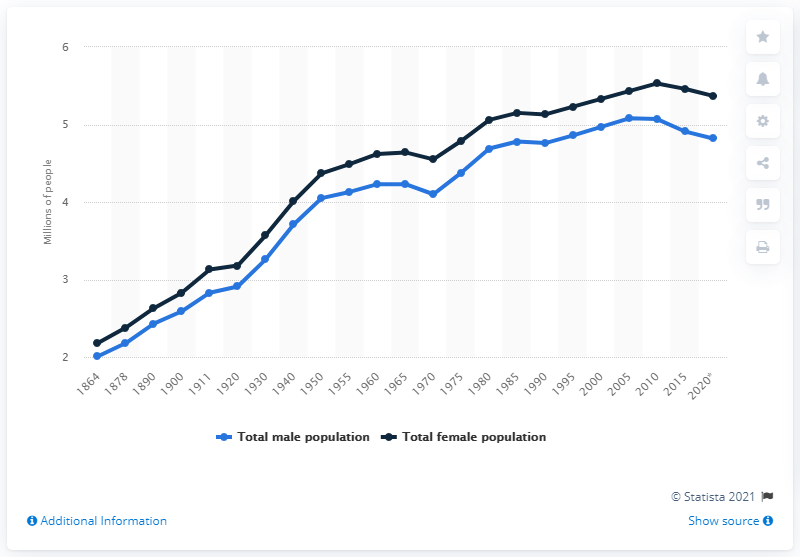Specify some key components in this picture. Since 1864, it has consistently been the case that more women than men have been alive at any given time. In the first entry, there were 2.01 people in Portugal. The number of men began to decrease before the number of women in the year 2005. 